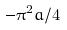<formula> <loc_0><loc_0><loc_500><loc_500>- \pi ^ { 2 } a / 4</formula> 